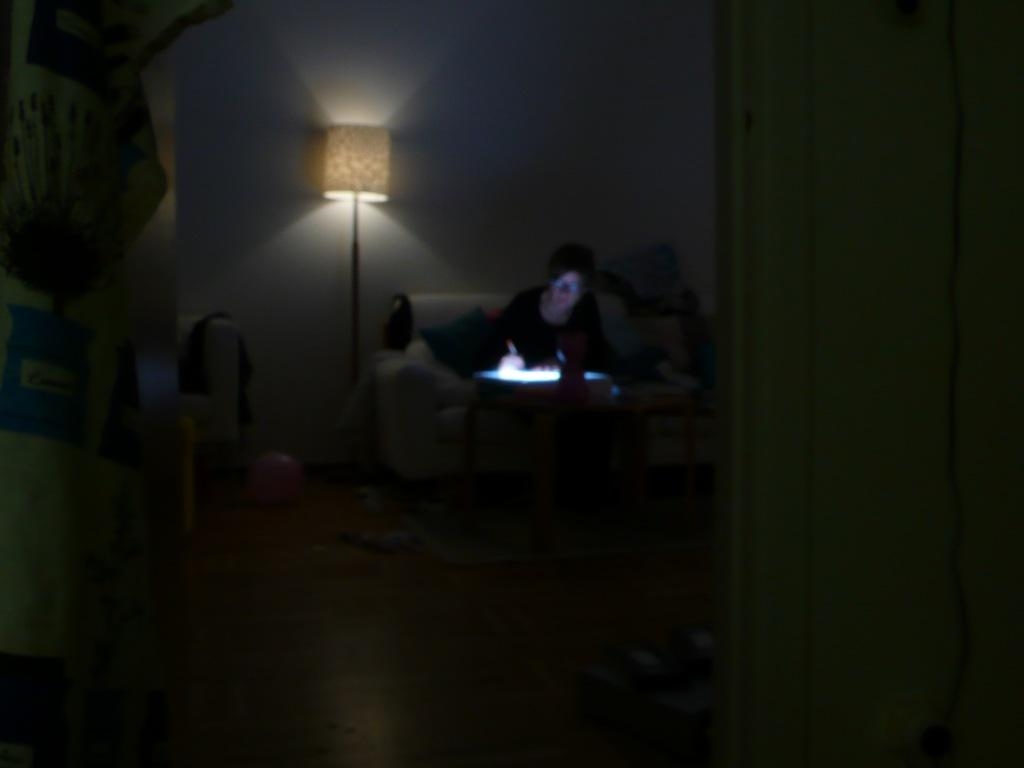What is the person in the image doing? The person is sitting on a couch. What is on the couch with the person? The couch has pillows. What is in front of the person? There is a table in front of the person. What is on the table? There is a lamp on the table. What is on the floor? There is a carpet on the floor, as well as a ball and other things. What type of drug can be seen on the roof in the image? There is no drug or roof present in the image; it features a person sitting on a couch with a table, lamp, carpet, ball, and other things on the floor. 